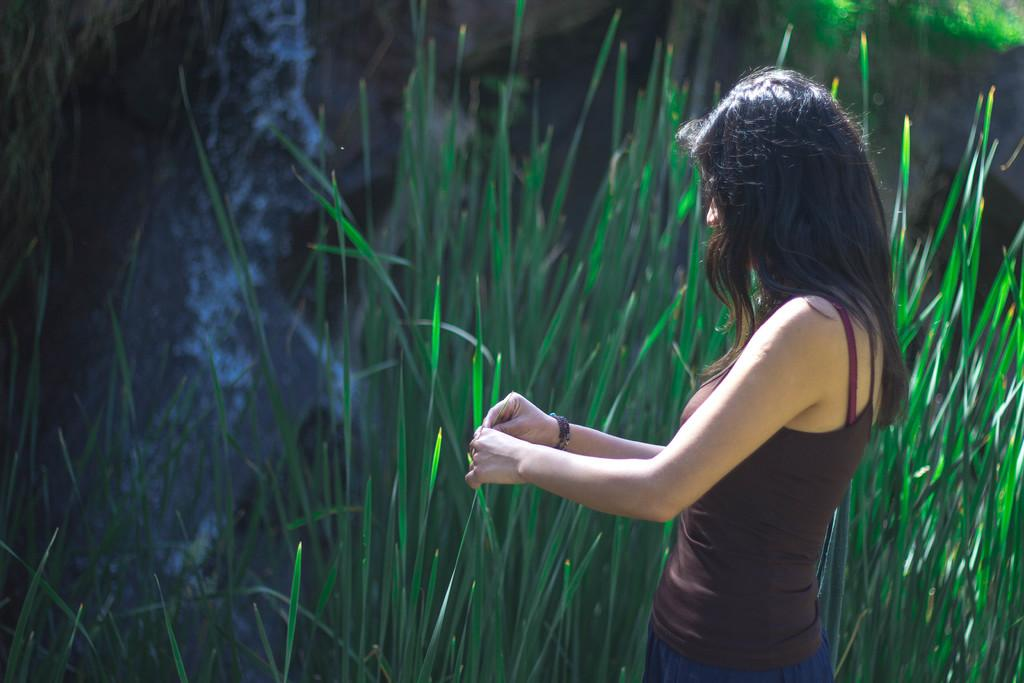What is the lady on the left side of the image doing? The lady is standing on the left side of the image. What is the lady wearing? The lady is wearing a dress. What is the lady holding in her hand? The lady is holding a leaf. What can be seen in the background of the image? There are plants, rocks, and a waterfall in the background of the image. What type of waves can be seen in the image? There are no waves present in the image. Is there a visitor playing a guitar in the image? There is no visitor or guitar present in the image. 